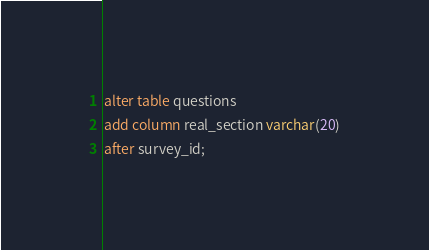Convert code to text. <code><loc_0><loc_0><loc_500><loc_500><_SQL_>alter table questions
add column real_section varchar(20)
after survey_id;
</code> 